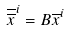Convert formula to latex. <formula><loc_0><loc_0><loc_500><loc_500>\overline { \overline { x } } ^ { i } = B \overline { x } ^ { i }</formula> 